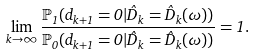<formula> <loc_0><loc_0><loc_500><loc_500>\lim _ { k \to \infty } \frac { \mathbb { P } _ { 1 } ( d _ { k + 1 } = 0 | \hat { D } _ { k } = \hat { D } _ { k } ( \omega ) ) } { \mathbb { P } _ { 0 } ( d _ { k + 1 } = 0 | \hat { D } _ { k } = \hat { D } _ { k } ( \omega ) ) } = 1 .</formula> 